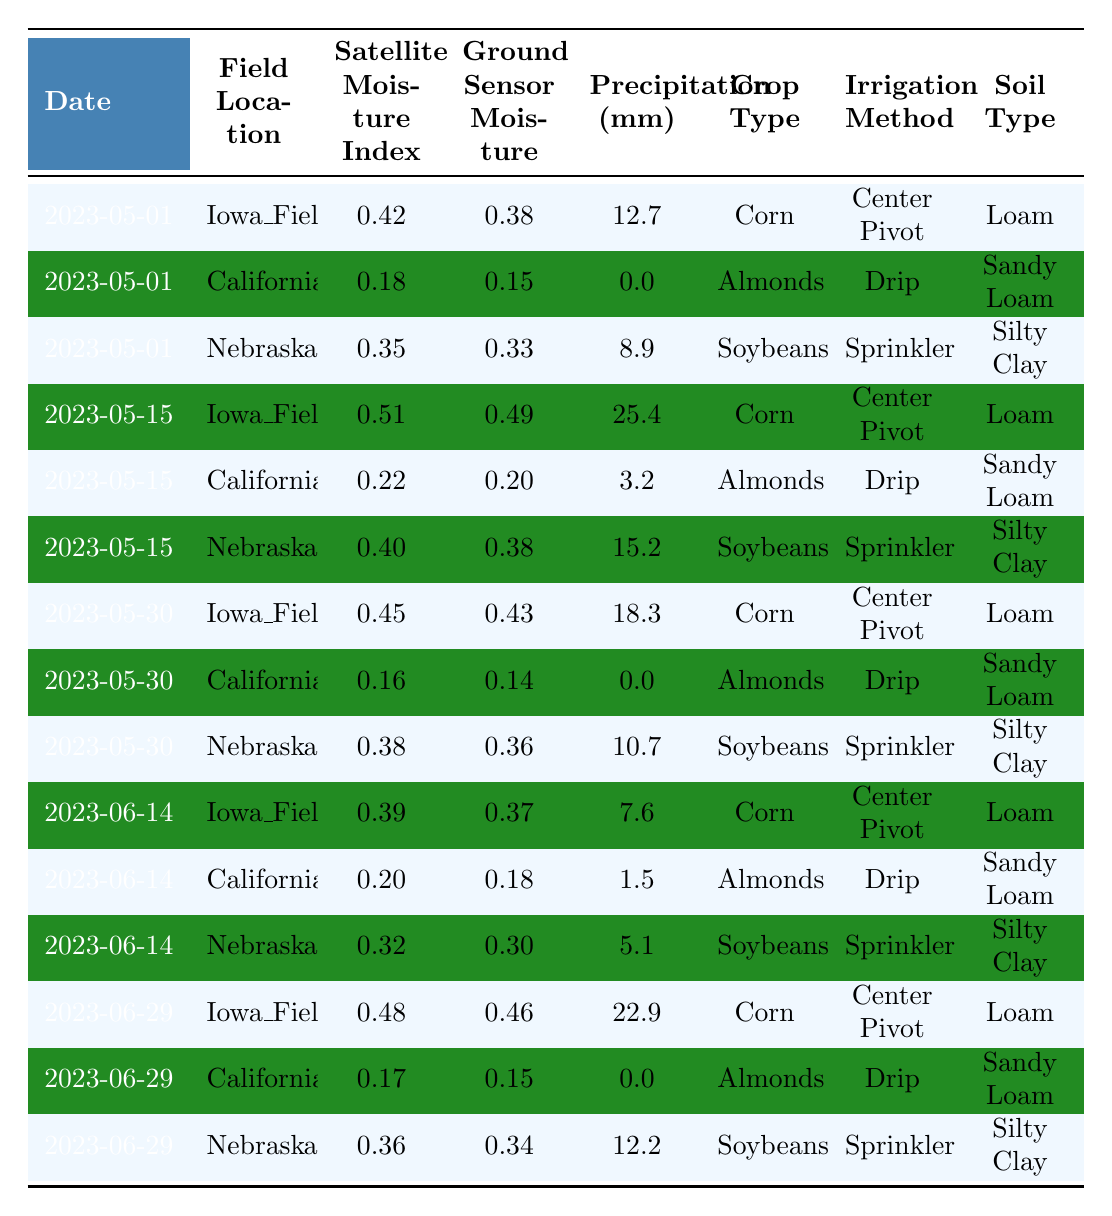What is the highest Satellite Imagery Moisture Index recorded in the table? By reviewing the 'Satellite Imagery Moisture Index' column, the highest value is 0.51, which occurs at Iowa_Field_1 on 2023-05-15.
Answer: 0.51 What is the average Ground Sensor Moisture Level for Iowa_Field_1? For Iowa_Field_1, the values are 0.38, 0.49, 0.43, 0.37, and 0.46. Summing these: (0.38 + 0.49 + 0.43 + 0.37 + 0.46) = 2.13. Dividing by 5 gives an average of 2.13/5 = 0.426.
Answer: 0.426 On which date did Nebraska_Field_3 receive the most precipitation? By checking the 'Precipitation (mm)' column for Nebraska_Field_3, the values are 8.9, 15.2, 10.7, 5.1, and 12.2. The maximum occurs on 2023-05-15 with 15.2 mm.
Answer: 2023-05-15 Is the irrigation method for California_Field_2 consistent across all recorded dates? Examining California_Field_2, we see the irrigation method listed is always 'Drip' across all entries. Therefore, it is consistent.
Answer: Yes What is the total amount of precipitation for all entries in the table? The total precipitation can be computed by summing all values: 12.7 + 0.0 + 8.9 + 25.4 + 3.2 + 15.2 + 18.3 + 0.0 + 10.7 + 7.6 + 1.5 + 5.1 + 22.9 + 0.0 + 12.2 =  156.3 mm.
Answer: 156.3 mm Which crop type has the lowest Ground Sensor Moisture Level recorded? From the 'Ground Sensor Moisture Level' column, the lowest value is 0.14, which corresponds to California_Field_2 on 2023-05-30 for the crop type Almonds.
Answer: Almonds Over all the recorded dates, what percentage of the entries have a Satellite Imagery Moisture Index greater than 0.40? Five entries have a Satellite Imagery Moisture Index greater than 0.40: 0.42, 0.51, 0.45, 0.40, and 0.48. There are a total of 15 entries, so (5/15)*100 = 33.33%.
Answer: 33.33% Is there a correlation between soil type and the moisture levels observed in the table? Analyzing the table shows that moisture levels fluctuate across different soil types, but further statistical correlation analysis would be necessary for a definite conclusion, indicating variability rather than a clear correlation.
Answer: Uncertain, requires more analysis What is the average moisture index for corn across all fields and dates? The moisture indexes for corn at Iowa_Field_1 on various dates are 0.42, 0.51, 0.45, 0.39, and 0.48. The average is (0.42 + 0.51 + 0.45 + 0.39 + 0.48)/5 = 0.45.
Answer: 0.45 What is the predominant soil type for the fields listed in the table? Reviewing the 'Soil Type' column, the predominant soil type appearing in the data is 'Loam', seen in 5 out of the total 15 entries.
Answer: Loam 